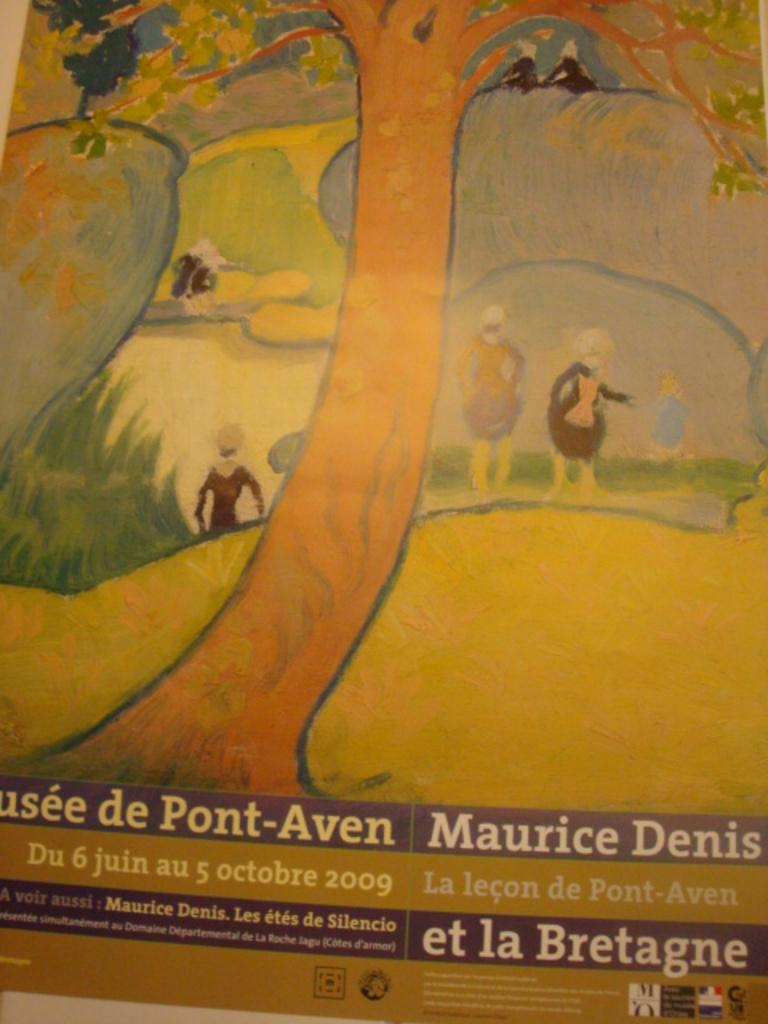<image>
Offer a succinct explanation of the picture presented. A flyer for Maurice Denis that is took place on the 5th of October 2009. 